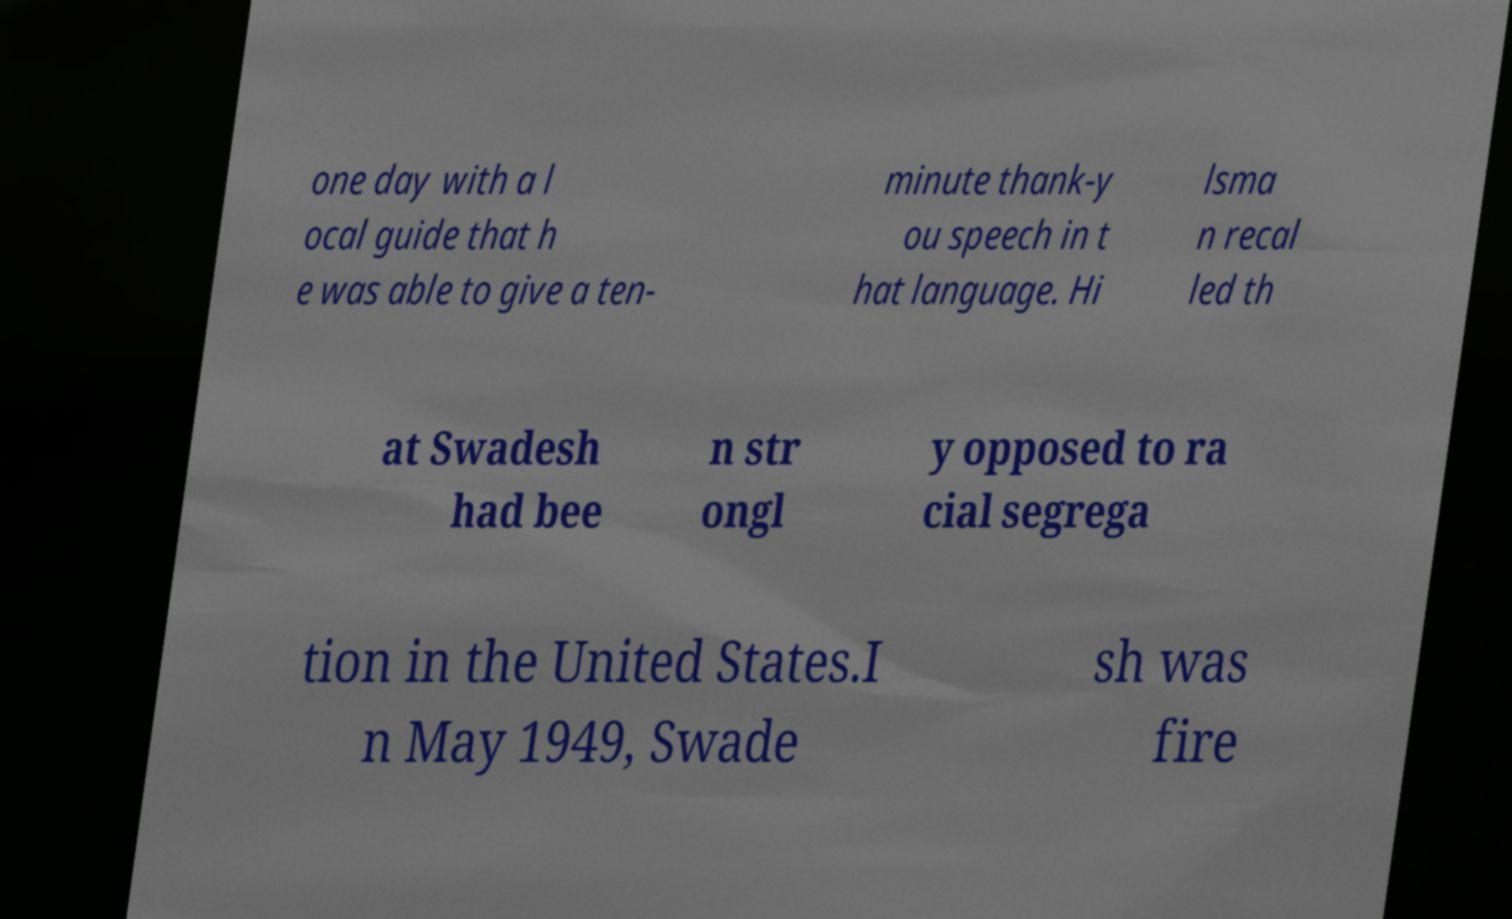There's text embedded in this image that I need extracted. Can you transcribe it verbatim? one day with a l ocal guide that h e was able to give a ten- minute thank-y ou speech in t hat language. Hi lsma n recal led th at Swadesh had bee n str ongl y opposed to ra cial segrega tion in the United States.I n May 1949, Swade sh was fire 